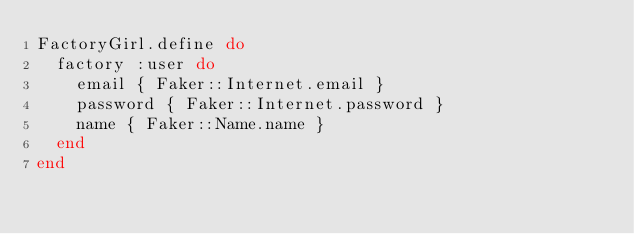<code> <loc_0><loc_0><loc_500><loc_500><_Ruby_>FactoryGirl.define do
  factory :user do
    email { Faker::Internet.email }
    password { Faker::Internet.password }
    name { Faker::Name.name }
  end
end
</code> 